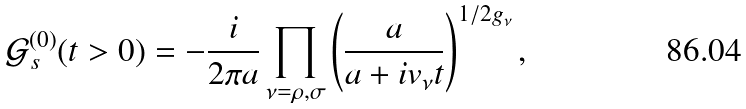<formula> <loc_0><loc_0><loc_500><loc_500>\mathcal { G } _ { s } ^ { ( 0 ) } ( t > 0 ) = - \frac { i } { 2 \pi a } \prod _ { \nu = \rho , \sigma } \left ( \frac { a } { a + i v _ { \nu } t } \right ) ^ { 1 / 2 g _ { \nu } } ,</formula> 